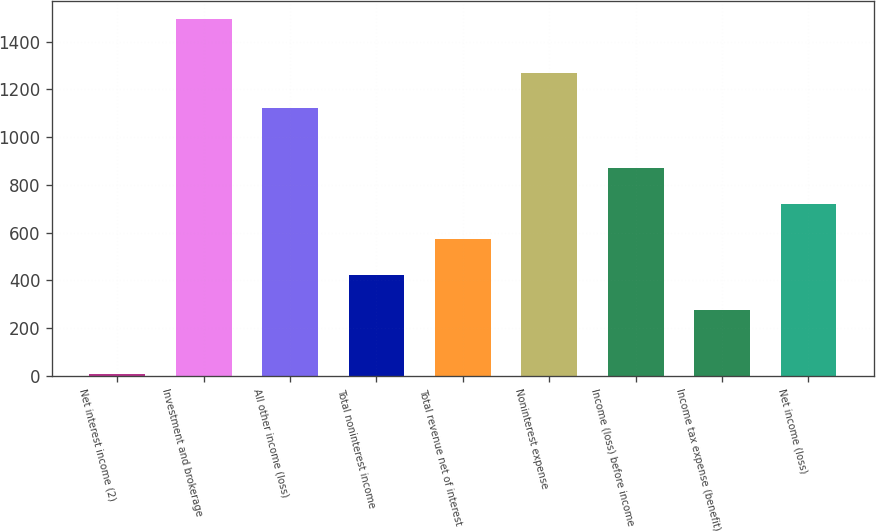Convert chart to OTSL. <chart><loc_0><loc_0><loc_500><loc_500><bar_chart><fcel>Net interest income (2)<fcel>Investment and brokerage<fcel>All other income (loss)<fcel>Total noninterest income<fcel>Total revenue net of interest<fcel>Noninterest expense<fcel>Income (loss) before income<fcel>Income tax expense (benefit)<fcel>Net income (loss)<nl><fcel>6<fcel>1496<fcel>1120<fcel>424<fcel>573<fcel>1269<fcel>871<fcel>275<fcel>722<nl></chart> 